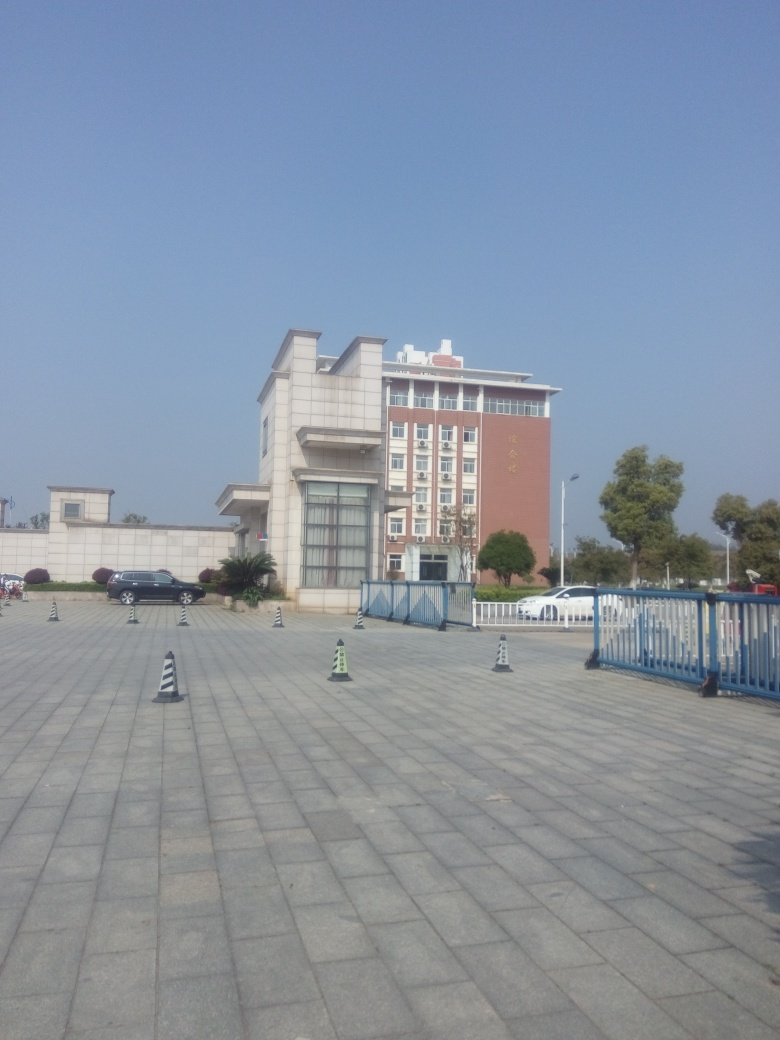What is the likely function of this building? The building exudes a formal and institutional aura, suggested by its size and facade. It could serve as an administrative center, an educational facility like a university building, or maybe a corporate office, judging by the signage and flags which are common markers for such establishments. 